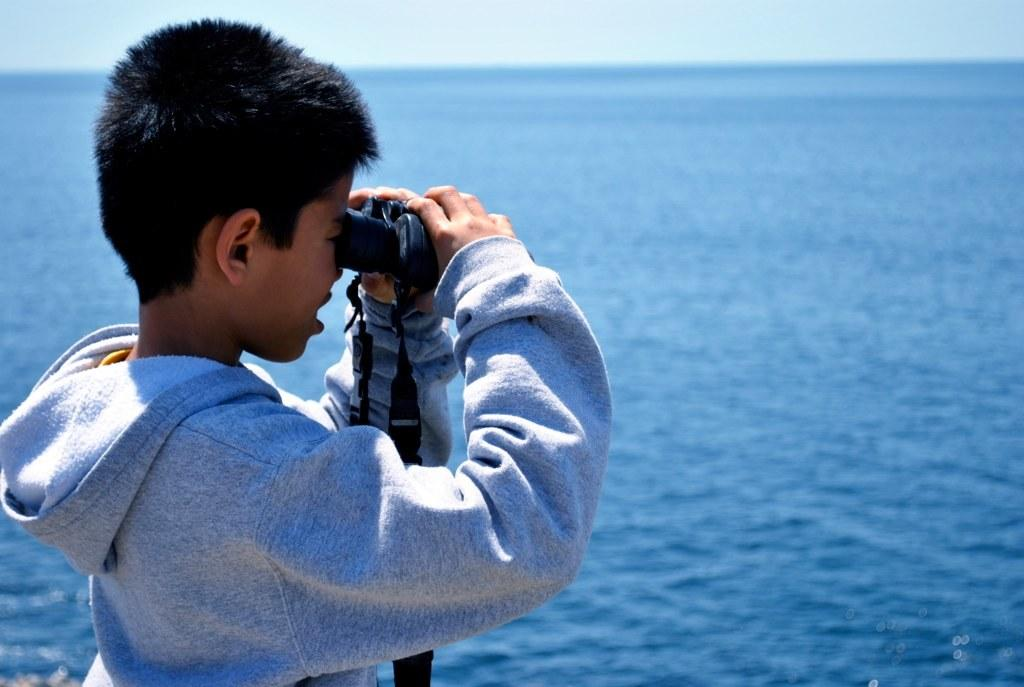Who is the main subject in the image? There is a boy in the image. What is the boy holding in the image? The boy is holding a binocular. What can be seen in the background of the image? There is water visible in the background of the image. What else is visible in the image? The sky is visible in the image. What type of wax is being used to create an attraction in the image? There is no attraction or wax present in the image. What is the boy's role in the ongoing war in the image? There is no war or indication of conflict in the image. 